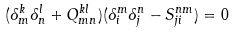Convert formula to latex. <formula><loc_0><loc_0><loc_500><loc_500>( \delta ^ { k } _ { m } \delta ^ { l } _ { n } + Q ^ { k l } _ { m n } ) ( \delta ^ { m } _ { i } \delta ^ { n } _ { j } - S ^ { n m } _ { j i } ) = 0</formula> 